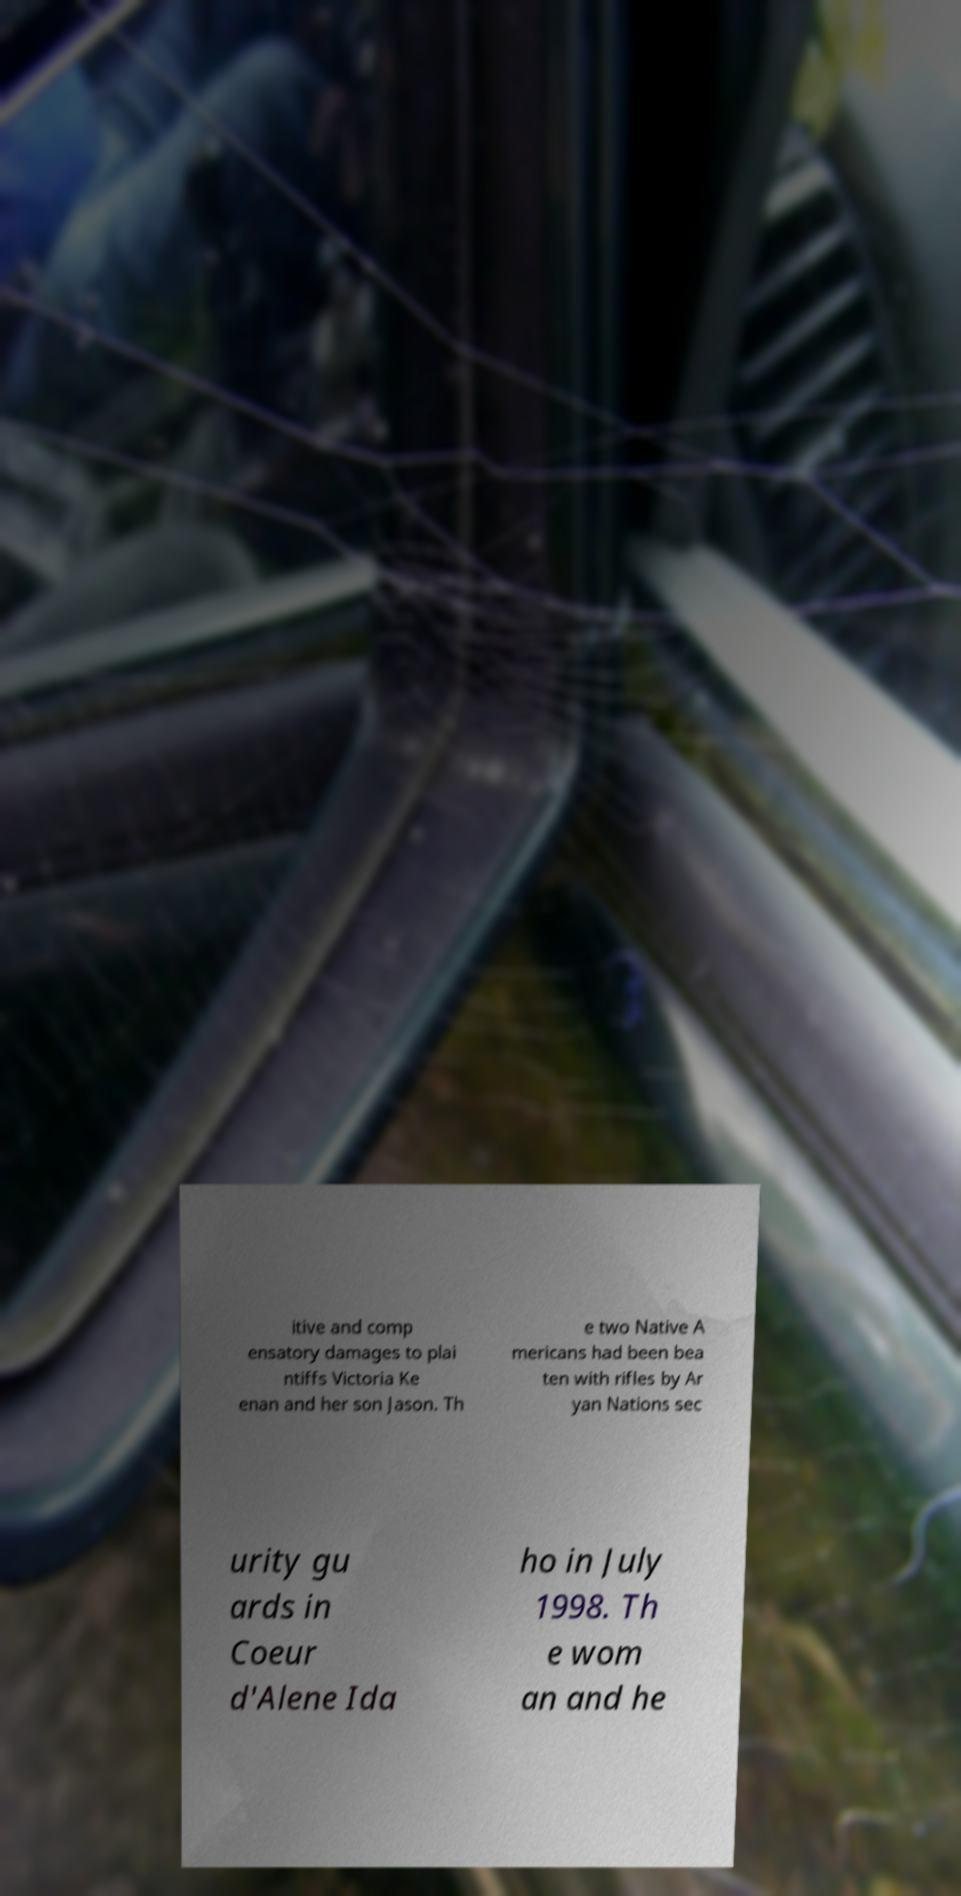Please read and relay the text visible in this image. What does it say? itive and comp ensatory damages to plai ntiffs Victoria Ke enan and her son Jason. Th e two Native A mericans had been bea ten with rifles by Ar yan Nations sec urity gu ards in Coeur d'Alene Ida ho in July 1998. Th e wom an and he 